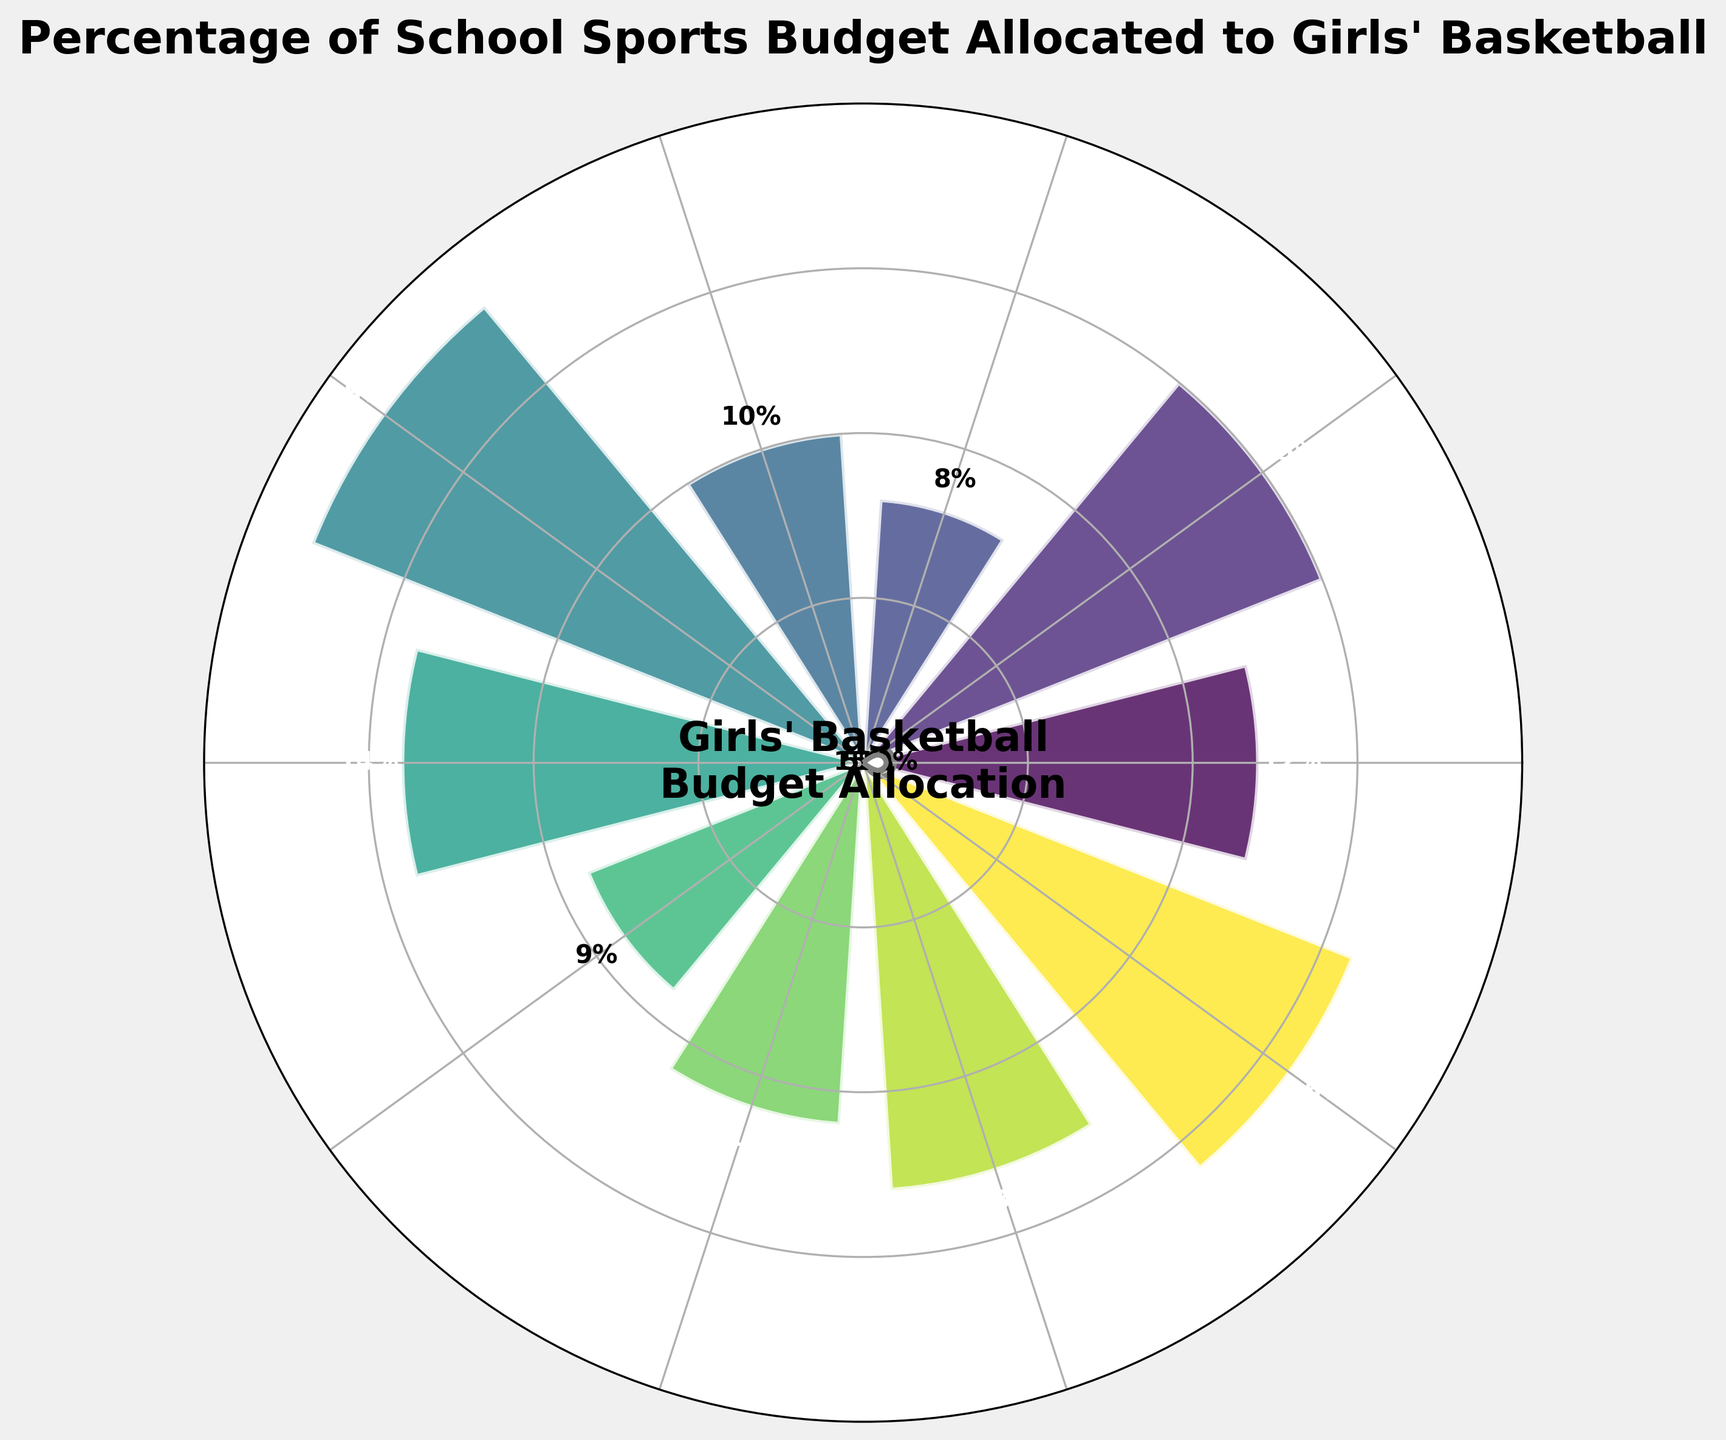what is the title of the figure? The title is located at the top of the chart and summarizes what the figure represents. The text reads "Percentage of School Sports Budget Allocated to Girls' Basketball".
Answer: Percentage of School Sports Budget Allocated to Girls' Basketball How many schools are included in the figure? The number of different color segments corresponds to the number of schools displayed in the figure. There are 10 distinct segments in the chart.
Answer: 10 Which school has the highest percentage allocation to girls' basketball? By looking at the length of different segments and the percentages labeled next to them, Madison High School has the highest percentage with an allocation of 18%.
Answer: Madison High School Which school has the smallest percentage allocation? By examining the percentage values, Washington High School has the smallest allocation with only 8%.
Answer: Washington High School What is the general range of percentage allocations for girls' basketball across these schools? The minimum and maximum values based on the chart are 8% and 18%, respectively, thus the range is 18% - 8% = 10%.
Answer: 8% to 18% What is the approximate average percentage allocation across all schools? Add all the percentage values and divide by the number of schools. (12+15+8+10+18+14+9+11+13+16)/10 = 126/10 = 12.6%
Answer: 12.6% How many schools allocate more than 10% of their sports budget to girls' basketball? Count the segments with values greater than 10%. Lincoln, Jefferson, Madison, Franklin, Monroe, and Cleveland allocate more than 10%. That's six schools.
Answer: 6 Do any schools allocate exactly 10%? Look for a segment directly labeled with 10%. Roosevelt High School allocates exactly 10%.
Answer: Roosevelt High School How does the allocation for Kennedy High School compare to the average allocation? The average allocation is around 12.6%. Kennedy High School allocates 9%, which is lower than the average.
Answer: Lower Which schools allocate between 12% and 15%? Identify and list the schools whose allocations fall within this range. These schools are Lincoln High School (12%), Franklin High School (14%), and Monroe High School (13%).
Answer: Lincoln High School, Franklin High School, Monroe High School 